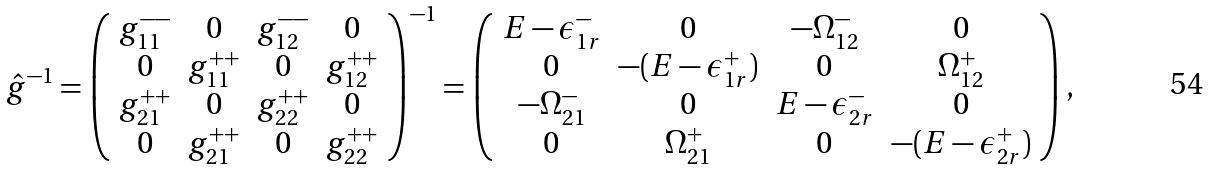Convert formula to latex. <formula><loc_0><loc_0><loc_500><loc_500>\hat { g } ^ { - 1 } = \left ( \begin{array} { c c c c } g _ { 1 1 } ^ { - - } & 0 & g _ { 1 2 } ^ { - - } & 0 \\ 0 & g _ { 1 1 } ^ { + + } & 0 & g _ { 1 2 } ^ { + + } \\ g _ { 2 1 } ^ { + + } & 0 & g _ { 2 2 } ^ { + + } & 0 \\ 0 & g _ { 2 1 } ^ { + + } & 0 & g _ { 2 2 } ^ { + + } \end{array} \right ) ^ { - 1 } = \left ( \begin{array} { c c c c } E - \epsilon _ { 1 r } ^ { - } & 0 & - \Omega _ { 1 2 } ^ { - } & 0 \\ 0 & - ( E - \epsilon _ { 1 r } ^ { + } ) & 0 & \Omega _ { 1 2 } ^ { + } \\ - \Omega _ { 2 1 } ^ { - } & 0 & E - \epsilon _ { 2 r } ^ { - } & 0 \\ 0 & \Omega _ { 2 1 } ^ { + } & 0 & - ( E - \epsilon _ { 2 r } ^ { + } ) \end{array} \right ) ,</formula> 